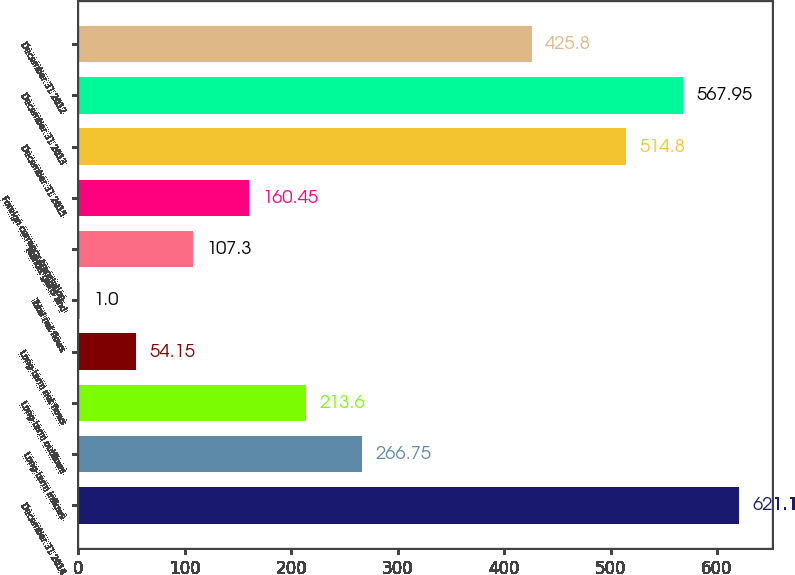<chart> <loc_0><loc_0><loc_500><loc_500><bar_chart><fcel>December 31 2014<fcel>Long-term inflows<fcel>Long-term outflows<fcel>Long-term net flows<fcel>Total net flows<fcel>Market gains and<fcel>Foreign currency translation<fcel>December 31 2015<fcel>December 31 2013<fcel>December 31 2012<nl><fcel>621.1<fcel>266.75<fcel>213.6<fcel>54.15<fcel>1<fcel>107.3<fcel>160.45<fcel>514.8<fcel>567.95<fcel>425.8<nl></chart> 